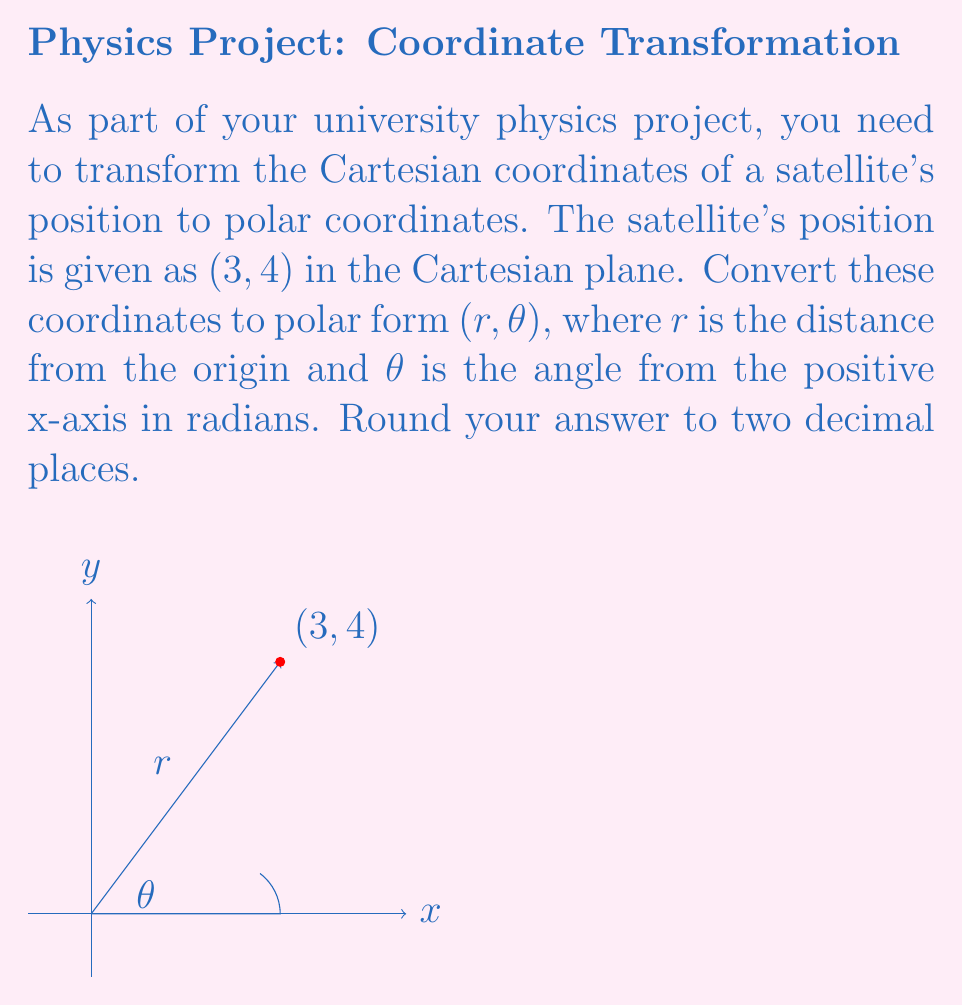Solve this math problem. To convert from Cartesian coordinates $(x, y)$ to polar coordinates $(r, \theta)$, we use the following formulas:

1. $r = \sqrt{x^2 + y^2}$
2. $\theta = \tan^{-1}(\frac{y}{x})$

For the given point (3, 4):

1. Calculate $r$:
   $$r = \sqrt{3^2 + 4^2} = \sqrt{9 + 16} = \sqrt{25} = 5$$

2. Calculate $\theta$:
   $$\theta = \tan^{-1}(\frac{4}{3}) \approx 0.9273 \text{ radians}$$

3. Round both values to two decimal places:
   $r \approx 5.00$
   $\theta \approx 0.93$ radians

Therefore, the polar coordinates are approximately (5.00, 0.93).
Answer: $(5.00, 0.93)$ 